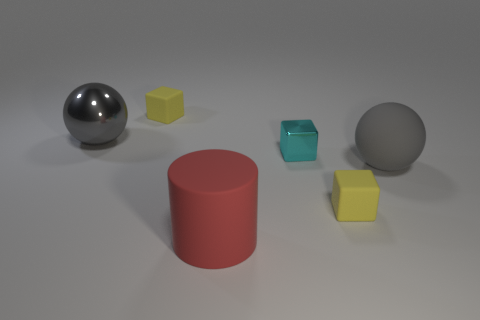Is there a rubber object of the same size as the cyan shiny block?
Your answer should be compact. Yes. What shape is the yellow object that is behind the large gray thing that is behind the gray thing to the right of the red object?
Provide a short and direct response. Cube. Are there more gray metallic balls that are on the left side of the large gray rubber sphere than small green metal objects?
Offer a terse response. Yes. Is there another gray object of the same shape as the large gray rubber thing?
Ensure brevity in your answer.  Yes. Is the material of the tiny cyan object the same as the gray ball that is to the left of the cyan cube?
Provide a succinct answer. Yes. The metal block has what color?
Provide a short and direct response. Cyan. There is a small yellow block that is in front of the yellow object that is to the left of the matte cylinder; what number of things are left of it?
Your answer should be compact. 4. Are there any gray things behind the gray rubber ball?
Offer a very short reply. Yes. How many tiny objects are made of the same material as the big cylinder?
Provide a short and direct response. 2. What number of objects are either green metallic cubes or big red rubber cylinders?
Keep it short and to the point. 1. 